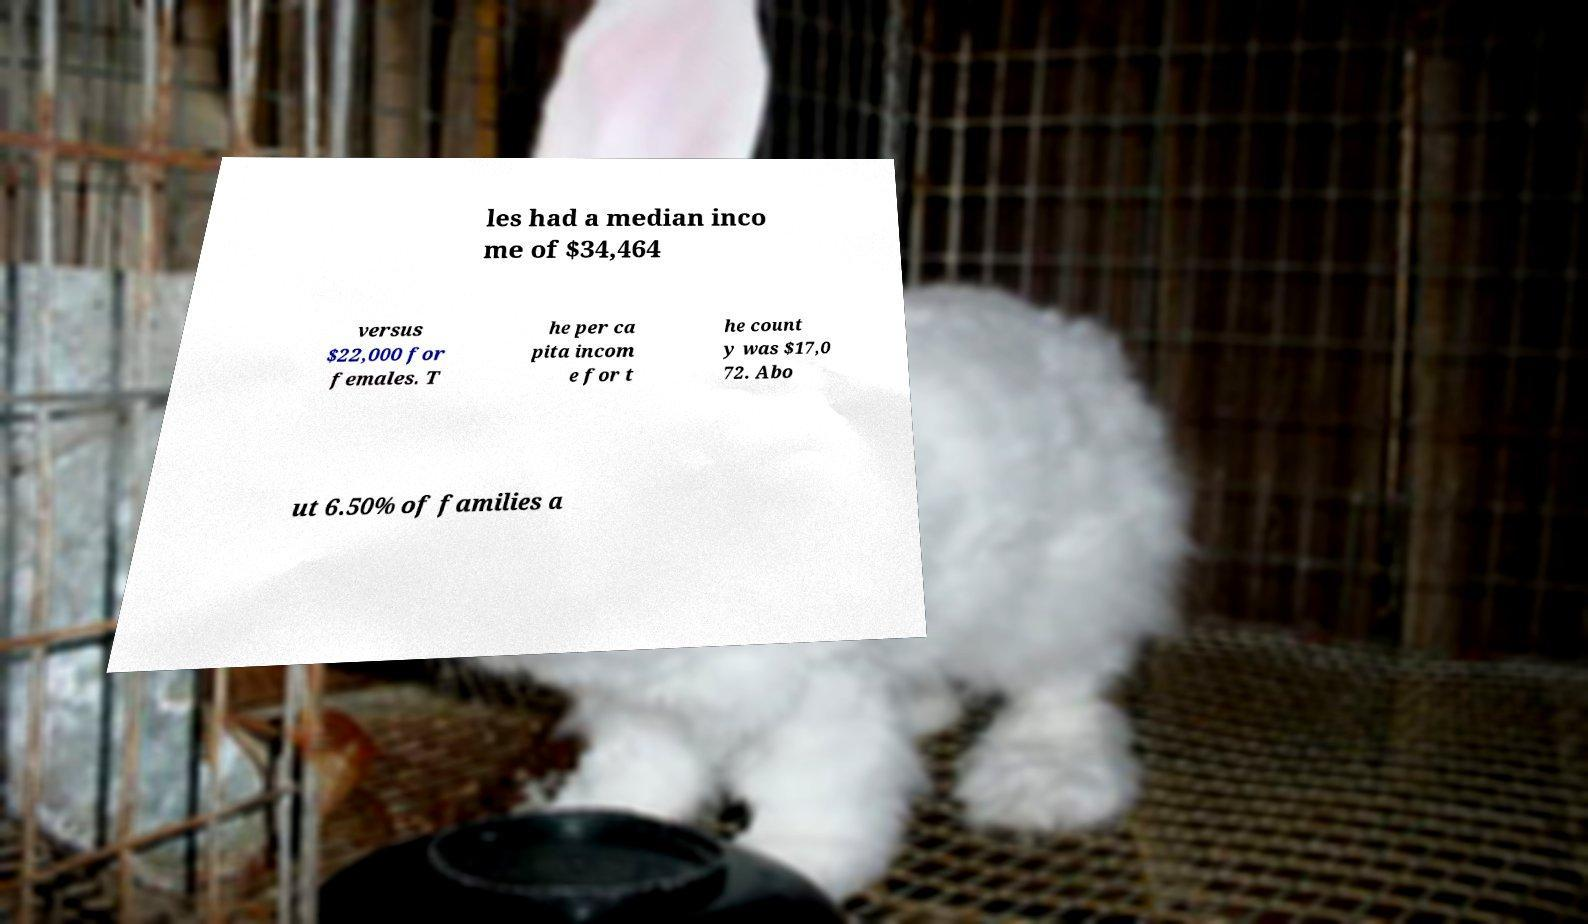Please read and relay the text visible in this image. What does it say? les had a median inco me of $34,464 versus $22,000 for females. T he per ca pita incom e for t he count y was $17,0 72. Abo ut 6.50% of families a 